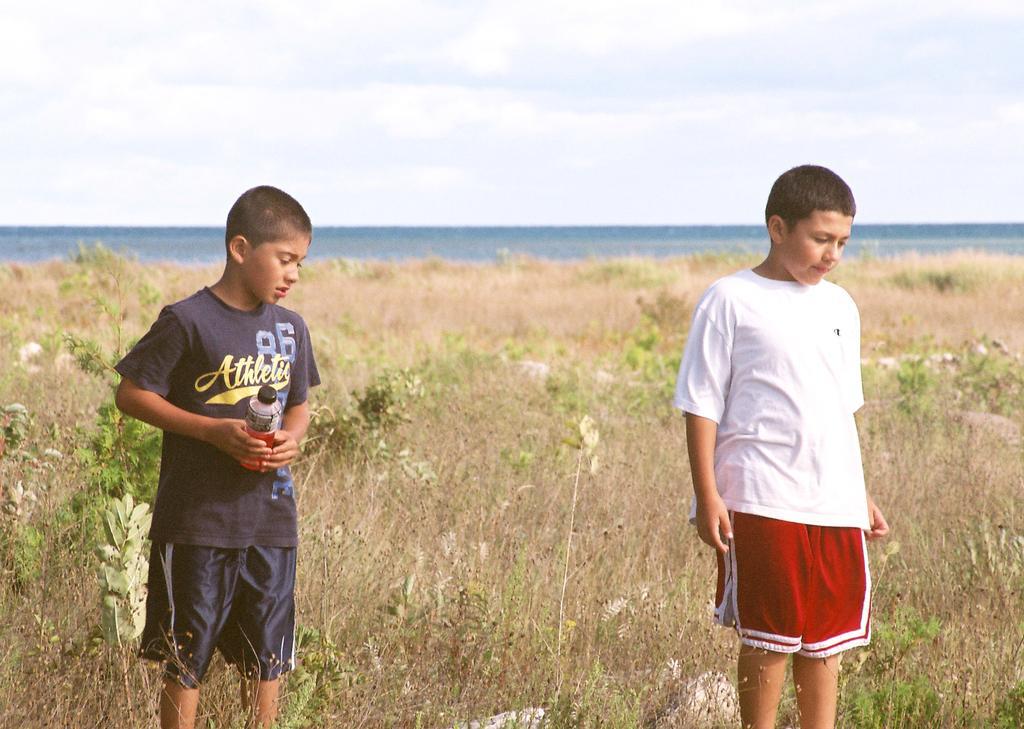Can you describe this image briefly? This picture is clicked outside. On the right we can see a person wearing white color T-shirt and standing. On the left we can see a person wearing T-shirt, holding a bottle and standing and we can see the plants, grass, sky and some other objects. 